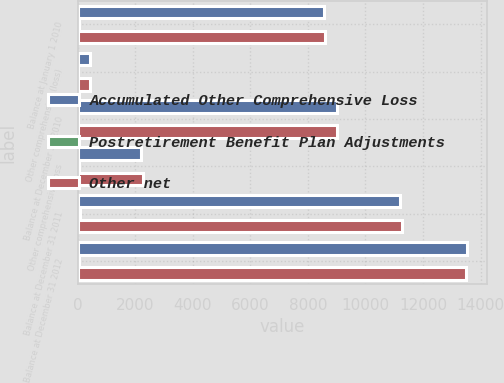<chart> <loc_0><loc_0><loc_500><loc_500><stacked_bar_chart><ecel><fcel>Balance at January 1 2010<fcel>Other comprehensive (loss)<fcel>Balance at December 31 2010<fcel>Other comprehensive loss<fcel>Balance at December 31 2011<fcel>Balance at December 31 2012<nl><fcel>Accumulated Other Comprehensive Loss<fcel>8564<fcel>430<fcel>8994<fcel>2192<fcel>11186<fcel>13532<nl><fcel>Postretirement Benefit Plan Adjustments<fcel>31<fcel>15<fcel>16<fcel>55<fcel>71<fcel>39<nl><fcel>Other net<fcel>8595<fcel>415<fcel>9010<fcel>2247<fcel>11257<fcel>13493<nl></chart> 